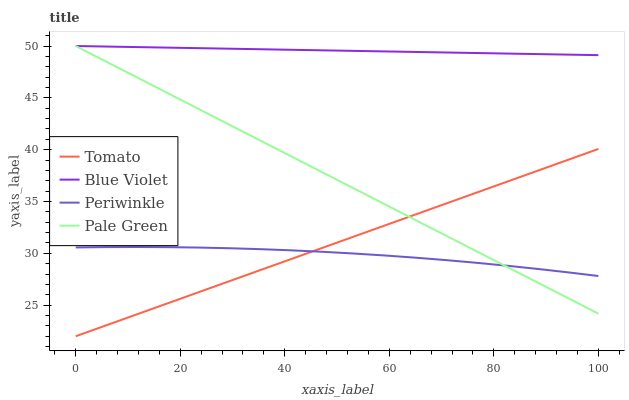Does Periwinkle have the minimum area under the curve?
Answer yes or no. Yes. Does Blue Violet have the maximum area under the curve?
Answer yes or no. Yes. Does Pale Green have the minimum area under the curve?
Answer yes or no. No. Does Pale Green have the maximum area under the curve?
Answer yes or no. No. Is Blue Violet the smoothest?
Answer yes or no. Yes. Is Periwinkle the roughest?
Answer yes or no. Yes. Is Pale Green the smoothest?
Answer yes or no. No. Is Pale Green the roughest?
Answer yes or no. No. Does Tomato have the lowest value?
Answer yes or no. Yes. Does Pale Green have the lowest value?
Answer yes or no. No. Does Blue Violet have the highest value?
Answer yes or no. Yes. Does Periwinkle have the highest value?
Answer yes or no. No. Is Periwinkle less than Blue Violet?
Answer yes or no. Yes. Is Blue Violet greater than Periwinkle?
Answer yes or no. Yes. Does Blue Violet intersect Pale Green?
Answer yes or no. Yes. Is Blue Violet less than Pale Green?
Answer yes or no. No. Is Blue Violet greater than Pale Green?
Answer yes or no. No. Does Periwinkle intersect Blue Violet?
Answer yes or no. No. 